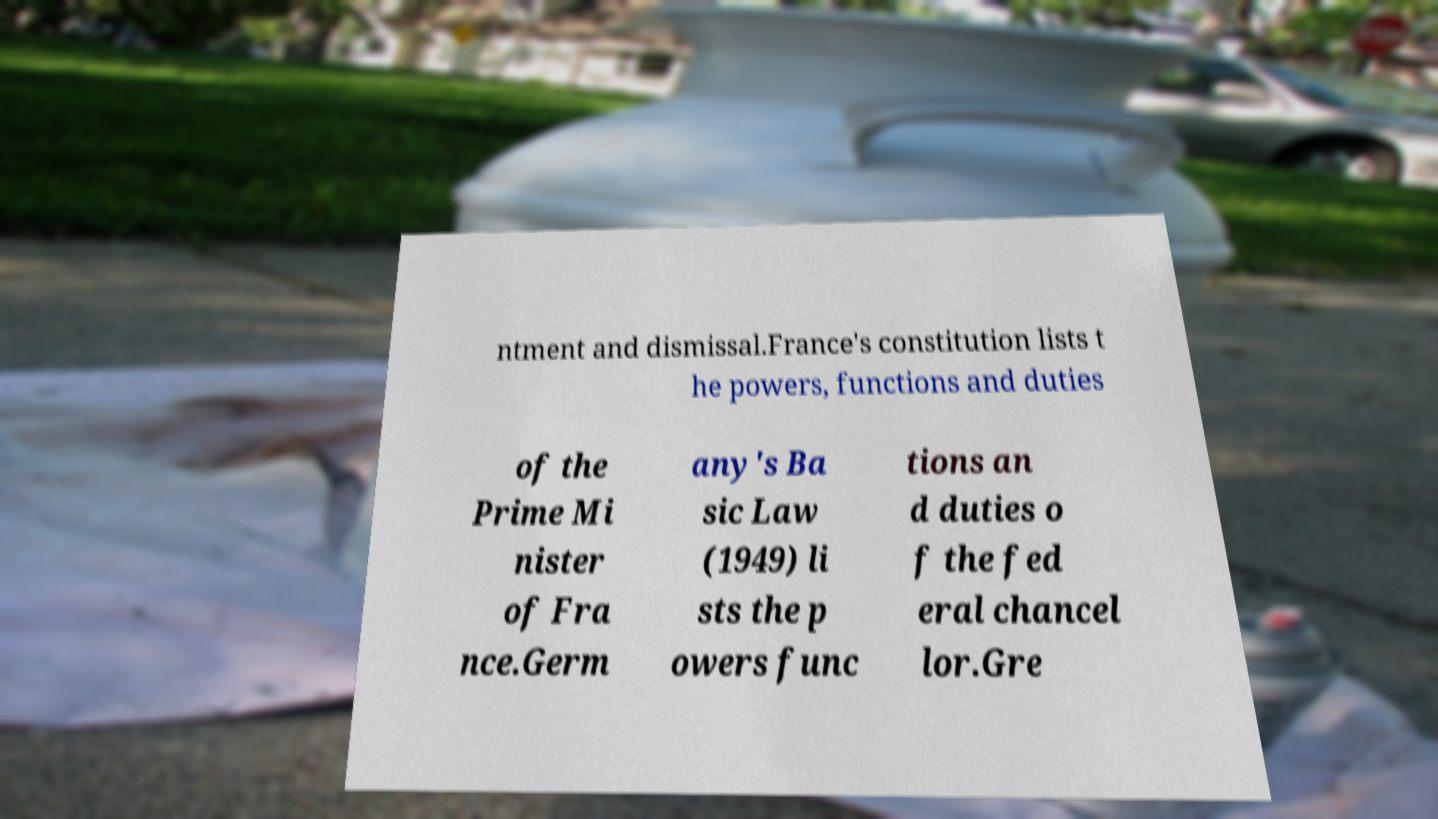There's text embedded in this image that I need extracted. Can you transcribe it verbatim? ntment and dismissal.France's constitution lists t he powers, functions and duties of the Prime Mi nister of Fra nce.Germ any's Ba sic Law (1949) li sts the p owers func tions an d duties o f the fed eral chancel lor.Gre 